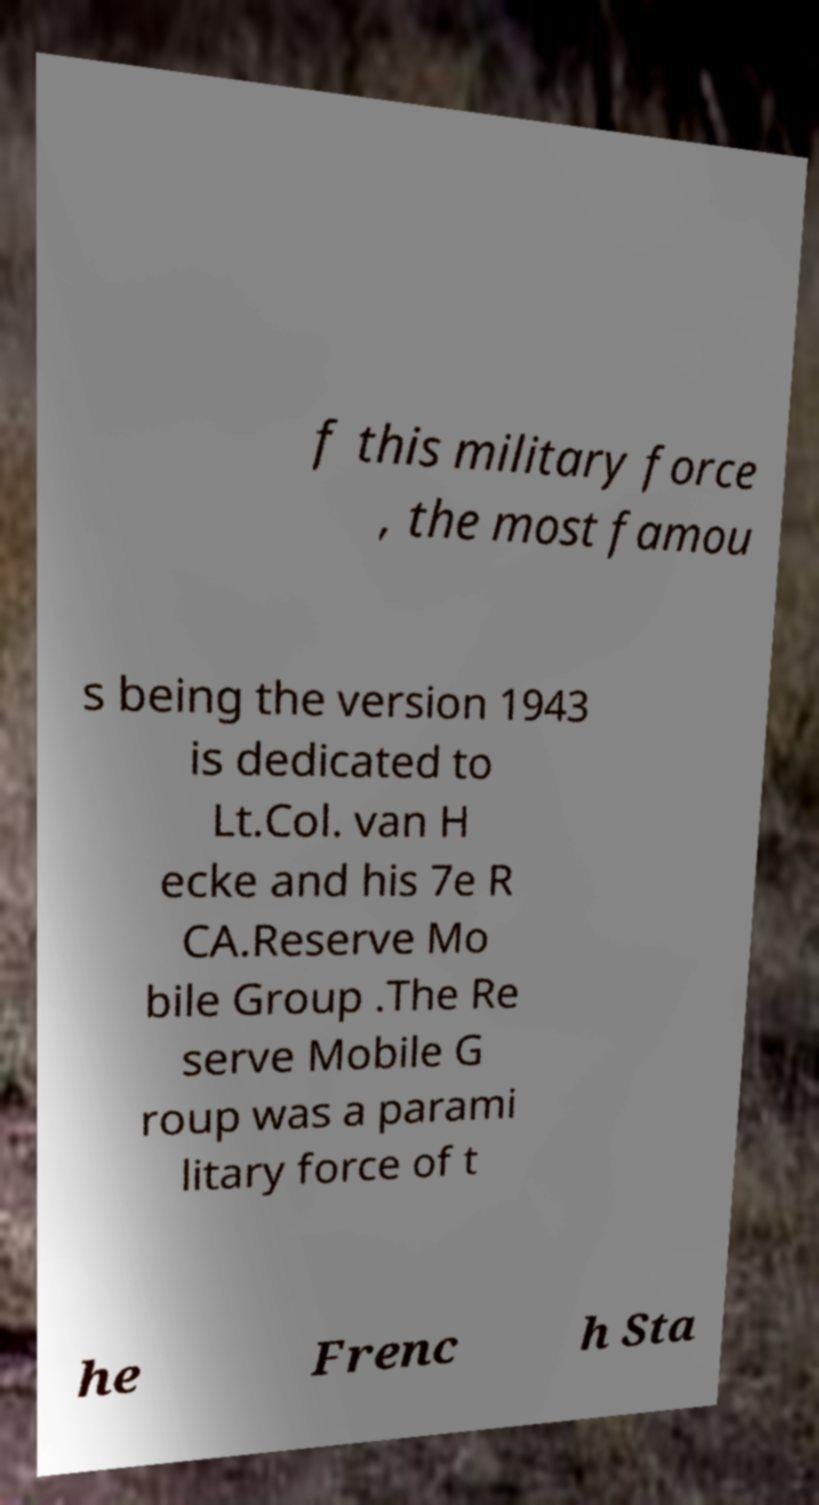For documentation purposes, I need the text within this image transcribed. Could you provide that? f this military force , the most famou s being the version 1943 is dedicated to Lt.Col. van H ecke and his 7e R CA.Reserve Mo bile Group .The Re serve Mobile G roup was a parami litary force of t he Frenc h Sta 